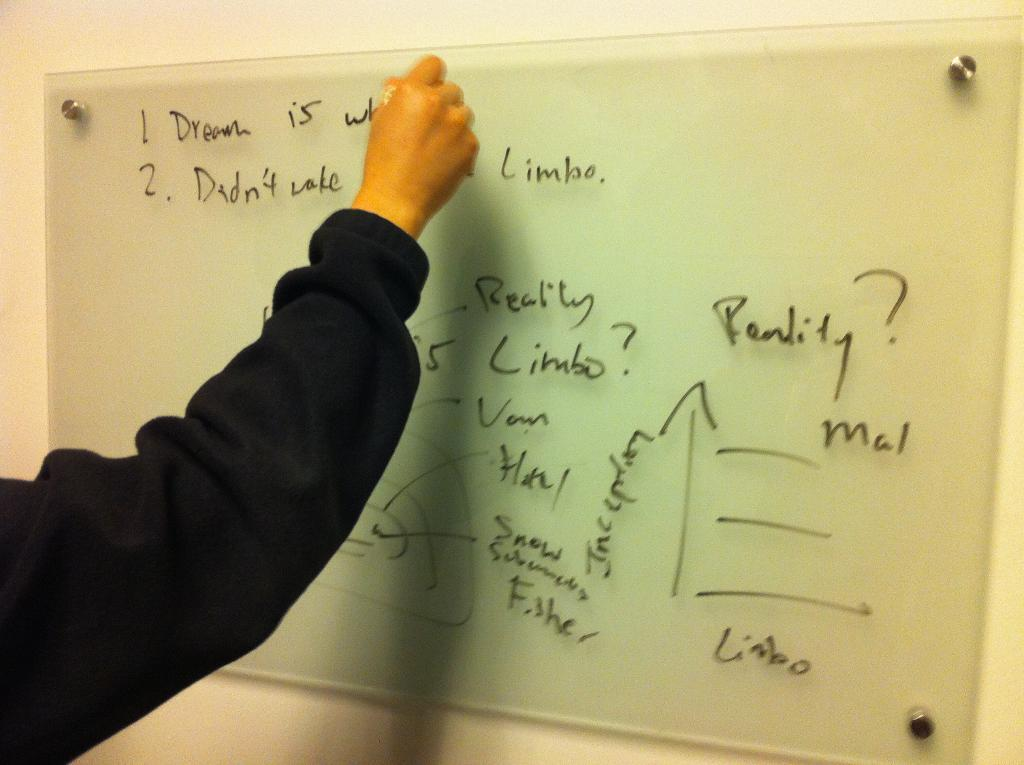Provide a one-sentence caption for the provided image. A hand is writing on a board, next to the word limbo. 